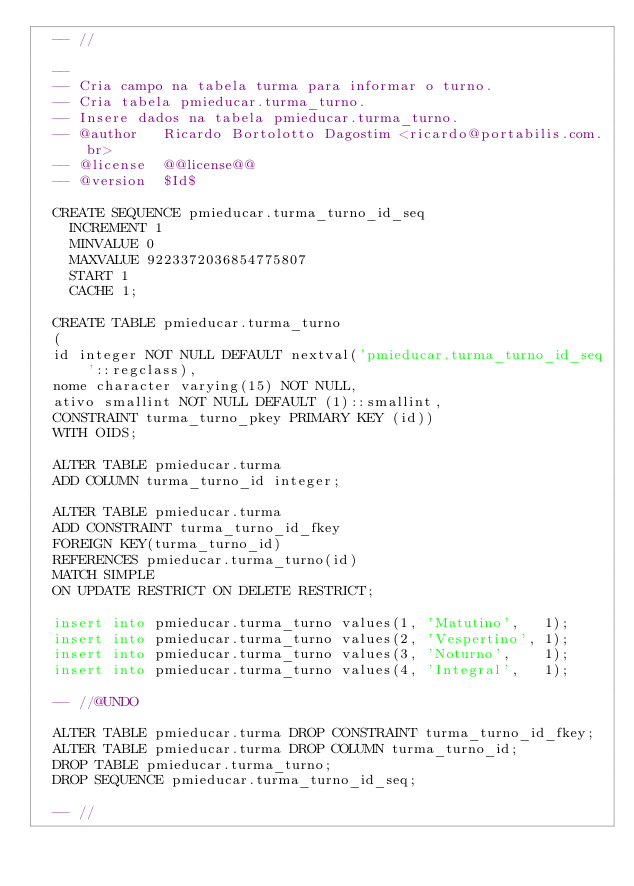Convert code to text. <code><loc_0><loc_0><loc_500><loc_500><_SQL_> 	-- //

 	--
 	-- Cria campo na tabela turma para informar o turno.
	-- Cria tabela pmieducar.turma_turno.
	-- Insere dados na tabela pmieducar.turma_turno.
 	-- @author   Ricardo Bortolotto Dagostim <ricardo@portabilis.com.br>
 	-- @license  @@license@@
 	-- @version  $Id$

	CREATE SEQUENCE pmieducar.turma_turno_id_seq
	  INCREMENT 1
	  MINVALUE 0
	  MAXVALUE 9223372036854775807
	  START 1
	  CACHE 1;

	CREATE TABLE pmieducar.turma_turno
	(
	id integer NOT NULL DEFAULT nextval('pmieducar.turma_turno_id_seq'::regclass),
	nome character varying(15) NOT NULL,
	ativo smallint NOT NULL DEFAULT (1)::smallint,
	CONSTRAINT turma_turno_pkey PRIMARY KEY (id))
	WITH OIDS;

	ALTER TABLE pmieducar.turma
	ADD COLUMN turma_turno_id integer;

	ALTER TABLE pmieducar.turma
	ADD CONSTRAINT turma_turno_id_fkey
	FOREIGN KEY(turma_turno_id)
	REFERENCES pmieducar.turma_turno(id)
	MATCH SIMPLE
	ON UPDATE RESTRICT ON DELETE RESTRICT;

	insert into pmieducar.turma_turno values(1, 'Matutino',   1);
	insert into pmieducar.turma_turno values(2, 'Vespertino', 1);
	insert into pmieducar.turma_turno values(3, 'Noturno',    1);
	insert into pmieducar.turma_turno values(4, 'Integral',   1);

	-- //@UNDO

	ALTER TABLE pmieducar.turma DROP CONSTRAINT turma_turno_id_fkey;
	ALTER TABLE pmieducar.turma DROP COLUMN turma_turno_id;
	DROP TABLE pmieducar.turma_turno;
	DROP SEQUENCE pmieducar.turma_turno_id_seq;

	-- //</code> 